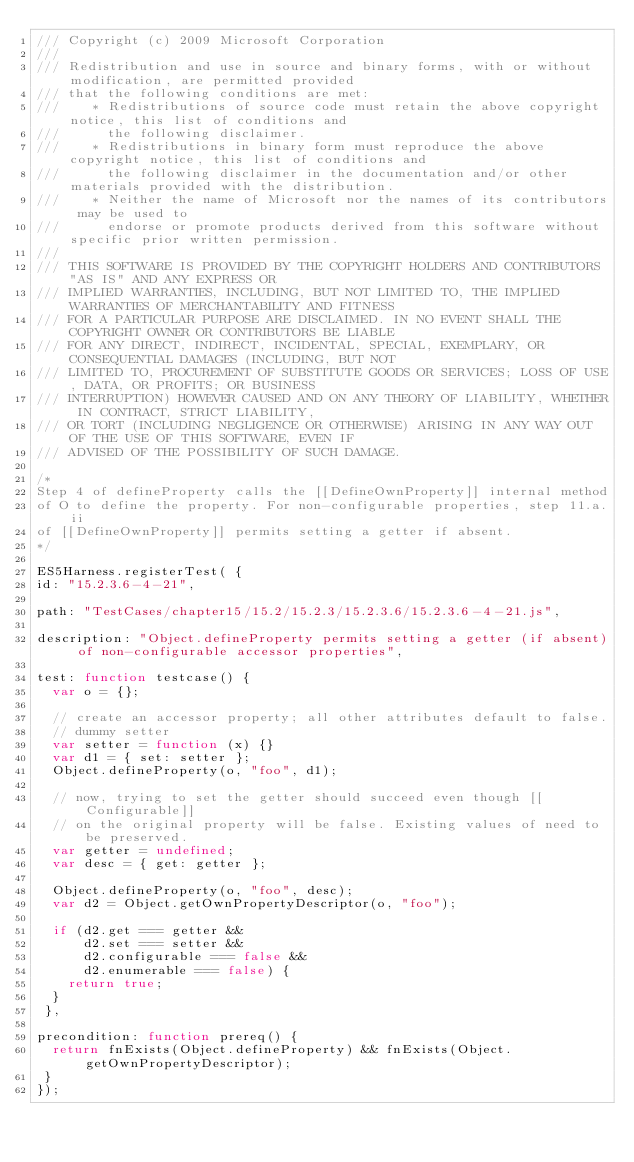<code> <loc_0><loc_0><loc_500><loc_500><_JavaScript_>/// Copyright (c) 2009 Microsoft Corporation 
/// 
/// Redistribution and use in source and binary forms, with or without modification, are permitted provided
/// that the following conditions are met: 
///    * Redistributions of source code must retain the above copyright notice, this list of conditions and
///      the following disclaimer. 
///    * Redistributions in binary form must reproduce the above copyright notice, this list of conditions and 
///      the following disclaimer in the documentation and/or other materials provided with the distribution.  
///    * Neither the name of Microsoft nor the names of its contributors may be used to
///      endorse or promote products derived from this software without specific prior written permission.
/// 
/// THIS SOFTWARE IS PROVIDED BY THE COPYRIGHT HOLDERS AND CONTRIBUTORS "AS IS" AND ANY EXPRESS OR
/// IMPLIED WARRANTIES, INCLUDING, BUT NOT LIMITED TO, THE IMPLIED WARRANTIES OF MERCHANTABILITY AND FITNESS
/// FOR A PARTICULAR PURPOSE ARE DISCLAIMED. IN NO EVENT SHALL THE COPYRIGHT OWNER OR CONTRIBUTORS BE LIABLE
/// FOR ANY DIRECT, INDIRECT, INCIDENTAL, SPECIAL, EXEMPLARY, OR CONSEQUENTIAL DAMAGES (INCLUDING, BUT NOT
/// LIMITED TO, PROCUREMENT OF SUBSTITUTE GOODS OR SERVICES; LOSS OF USE, DATA, OR PROFITS; OR BUSINESS
/// INTERRUPTION) HOWEVER CAUSED AND ON ANY THEORY OF LIABILITY, WHETHER IN CONTRACT, STRICT LIABILITY,
/// OR TORT (INCLUDING NEGLIGENCE OR OTHERWISE) ARISING IN ANY WAY OUT OF THE USE OF THIS SOFTWARE, EVEN IF
/// ADVISED OF THE POSSIBILITY OF SUCH DAMAGE. 

/*
Step 4 of defineProperty calls the [[DefineOwnProperty]] internal method
of O to define the property. For non-configurable properties, step 11.a.ii
of [[DefineOwnProperty]] permits setting a getter if absent.
*/

ES5Harness.registerTest( {
id: "15.2.3.6-4-21",

path: "TestCases/chapter15/15.2/15.2.3/15.2.3.6/15.2.3.6-4-21.js",

description: "Object.defineProperty permits setting a getter (if absent) of non-configurable accessor properties",

test: function testcase() {
  var o = {};

  // create an accessor property; all other attributes default to false.
  // dummy setter
  var setter = function (x) {}
  var d1 = { set: setter };
  Object.defineProperty(o, "foo", d1);

  // now, trying to set the getter should succeed even though [[Configurable]]
  // on the original property will be false. Existing values of need to be preserved.
  var getter = undefined;
  var desc = { get: getter };

  Object.defineProperty(o, "foo", desc);
  var d2 = Object.getOwnPropertyDescriptor(o, "foo");

  if (d2.get === getter &&
      d2.set === setter &&
      d2.configurable === false &&
      d2.enumerable === false) {
    return true;
  }
 },

precondition: function prereq() {
  return fnExists(Object.defineProperty) && fnExists(Object.getOwnPropertyDescriptor);
 }
});
</code> 